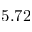<formula> <loc_0><loc_0><loc_500><loc_500>5 . 7 2</formula> 